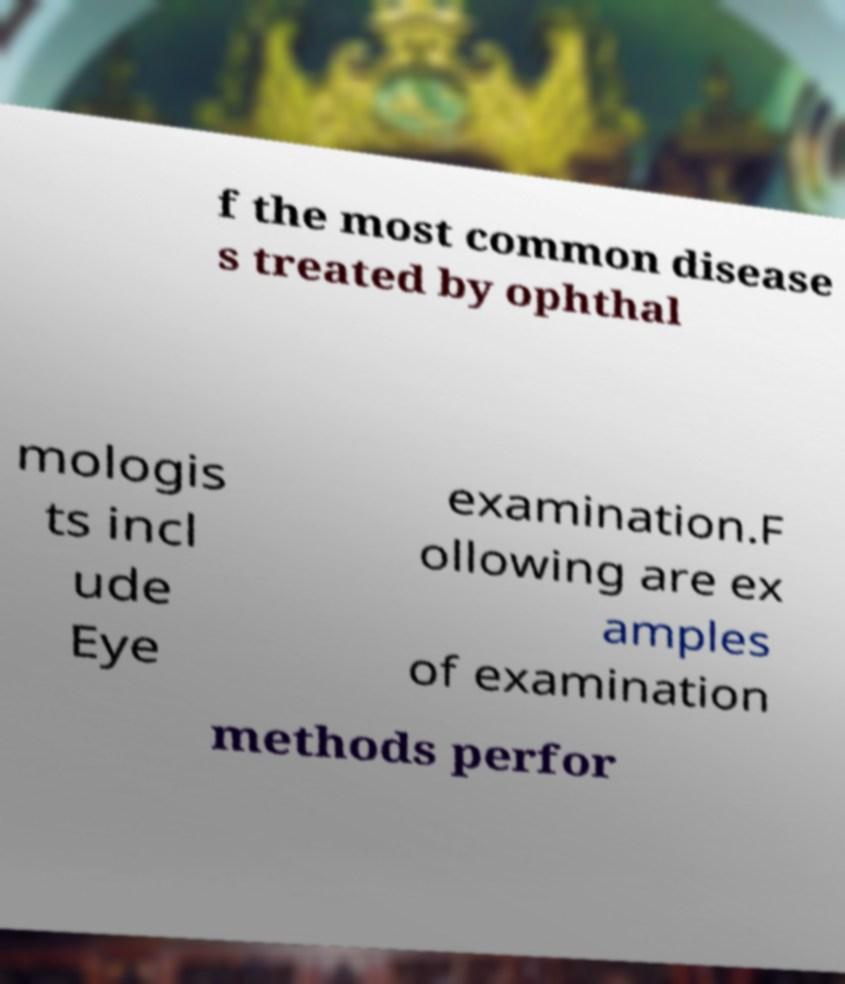Could you extract and type out the text from this image? f the most common disease s treated by ophthal mologis ts incl ude Eye examination.F ollowing are ex amples of examination methods perfor 